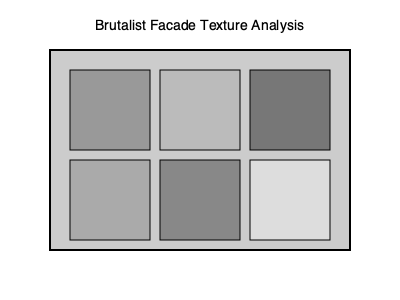Analyze the concrete textures depicted in the Brutalist facade diagram above. How do these varying textures contribute to the overall aesthetic and functional aspects of Brutalist architecture, and what specific techniques might have been used to achieve these effects? To analyze the concrete textures in the Brutalist facade, we need to consider several aspects:

1. Texture Variety: The diagram shows six different concrete textures, each with a unique shade and implied surface quality. This variety is crucial in Brutalist architecture for several reasons:

   a) Visual Interest: Different textures create a play of light and shadow, adding depth and complexity to the facade.
   b) Functional Differentiation: Varied textures can denote different functional areas or structural elements of the building.

2. Texture Techniques: The textures shown likely represent different concrete finishing methods:

   a) Smooth finish (lighter shades): Achieved by using finely-grained formwork or troweling.
   b) Rough finish (darker shades): Created by using coarse-grained formwork, bush-hammering, or leaving the concrete 'as-cast'.

3. Material Honesty: The exposed concrete textures embody the Brutalist principle of material honesty, where the structural material is left visible and celebrated.

4. Pattern and Rhythm: The arrangement of textures creates a grid-like pattern, a common feature in Brutalist design, emphasizing the modular nature of construction.

5. Weathering and Time: Different textures weather differently over time, contributing to the building's evolving aesthetic and patina.

6. Tactile Quality: Varied textures invite tactile interaction, making the building more engaging at a human scale.

7. Cost and Efficiency: Using different concrete finishes can be a cost-effective way to create visual interest without additional materials.

8. Environmental Response: Textured surfaces can affect how the building interacts with its environment, influencing factors like heat absorption and water runoff.

The specific techniques used to achieve these textures might include:

- Form-liners with different patterns
- Exposed aggregate finishes
- Board-marked concrete (using wooden formwork)
- Sand-blasting or acid-etching for smoother textures
- Bush-hammering or chiseling for rougher textures

These varied textures collectively contribute to the raw, monumental, and expressive character that defines Brutalist architecture.
Answer: Varied concrete textures create visual interest, functional differentiation, and embody Brutalist principles of material honesty and modularity, achieved through diverse finishing techniques like form-liners, exposed aggregate, and surface treatments. 